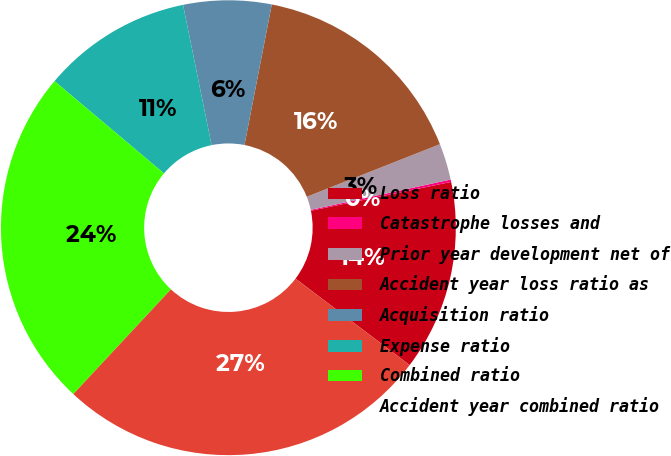Convert chart. <chart><loc_0><loc_0><loc_500><loc_500><pie_chart><fcel>Loss ratio<fcel>Catastrophe losses and<fcel>Prior year development net of<fcel>Accident year loss ratio as<fcel>Acquisition ratio<fcel>Expense ratio<fcel>Combined ratio<fcel>Accident year combined ratio<nl><fcel>13.55%<fcel>0.17%<fcel>2.59%<fcel>15.96%<fcel>6.25%<fcel>10.66%<fcel>24.21%<fcel>26.62%<nl></chart> 